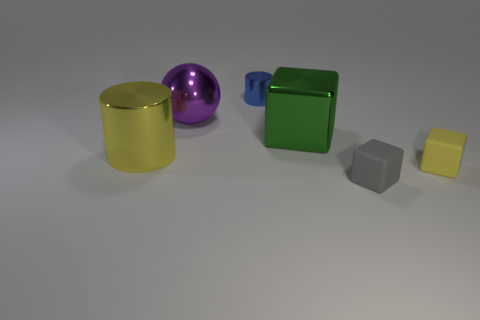There is a matte thing that is the same color as the large metal cylinder; what shape is it?
Offer a terse response. Cube. What is the color of the tiny cylinder?
Provide a succinct answer. Blue. There is a large metallic object that is in front of the large green object; is its color the same as the small block that is behind the tiny gray rubber block?
Offer a very short reply. Yes. The metallic block is what size?
Give a very brief answer. Large. There is a rubber thing to the left of the small yellow block; what is its size?
Provide a short and direct response. Small. There is a thing that is both to the left of the gray rubber object and in front of the large green metal cube; what is its shape?
Your answer should be very brief. Cylinder. What number of other objects are there of the same shape as the small blue shiny thing?
Your answer should be compact. 1. There is a cylinder that is the same size as the yellow matte thing; what is its color?
Provide a succinct answer. Blue. What number of objects are blue cylinders or large yellow matte cylinders?
Make the answer very short. 1. Are there any blue cylinders behind the yellow matte block?
Provide a short and direct response. Yes. 